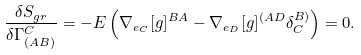Convert formula to latex. <formula><loc_0><loc_0><loc_500><loc_500>\frac { \delta S _ { g r } } { \delta \Gamma ^ { C } _ { ( A B ) } } = - E \left ( \nabla _ { e _ { C } } [ g ] ^ { B A } - \nabla _ { e _ { D } } [ g ] ^ { ( A D } \delta ^ { B ) } _ { C } \right ) = 0 .</formula> 